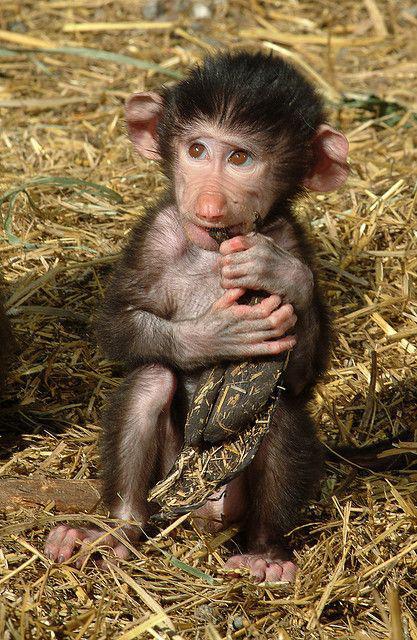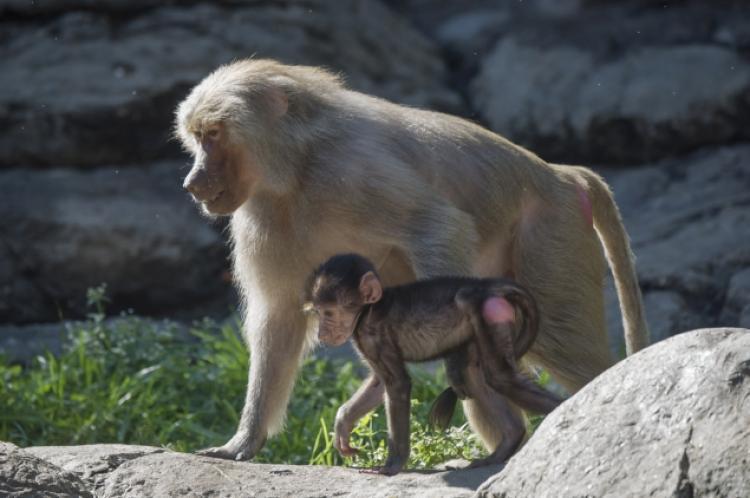The first image is the image on the left, the second image is the image on the right. Given the left and right images, does the statement "No monkey is photographed alone." hold true? Answer yes or no. No. 